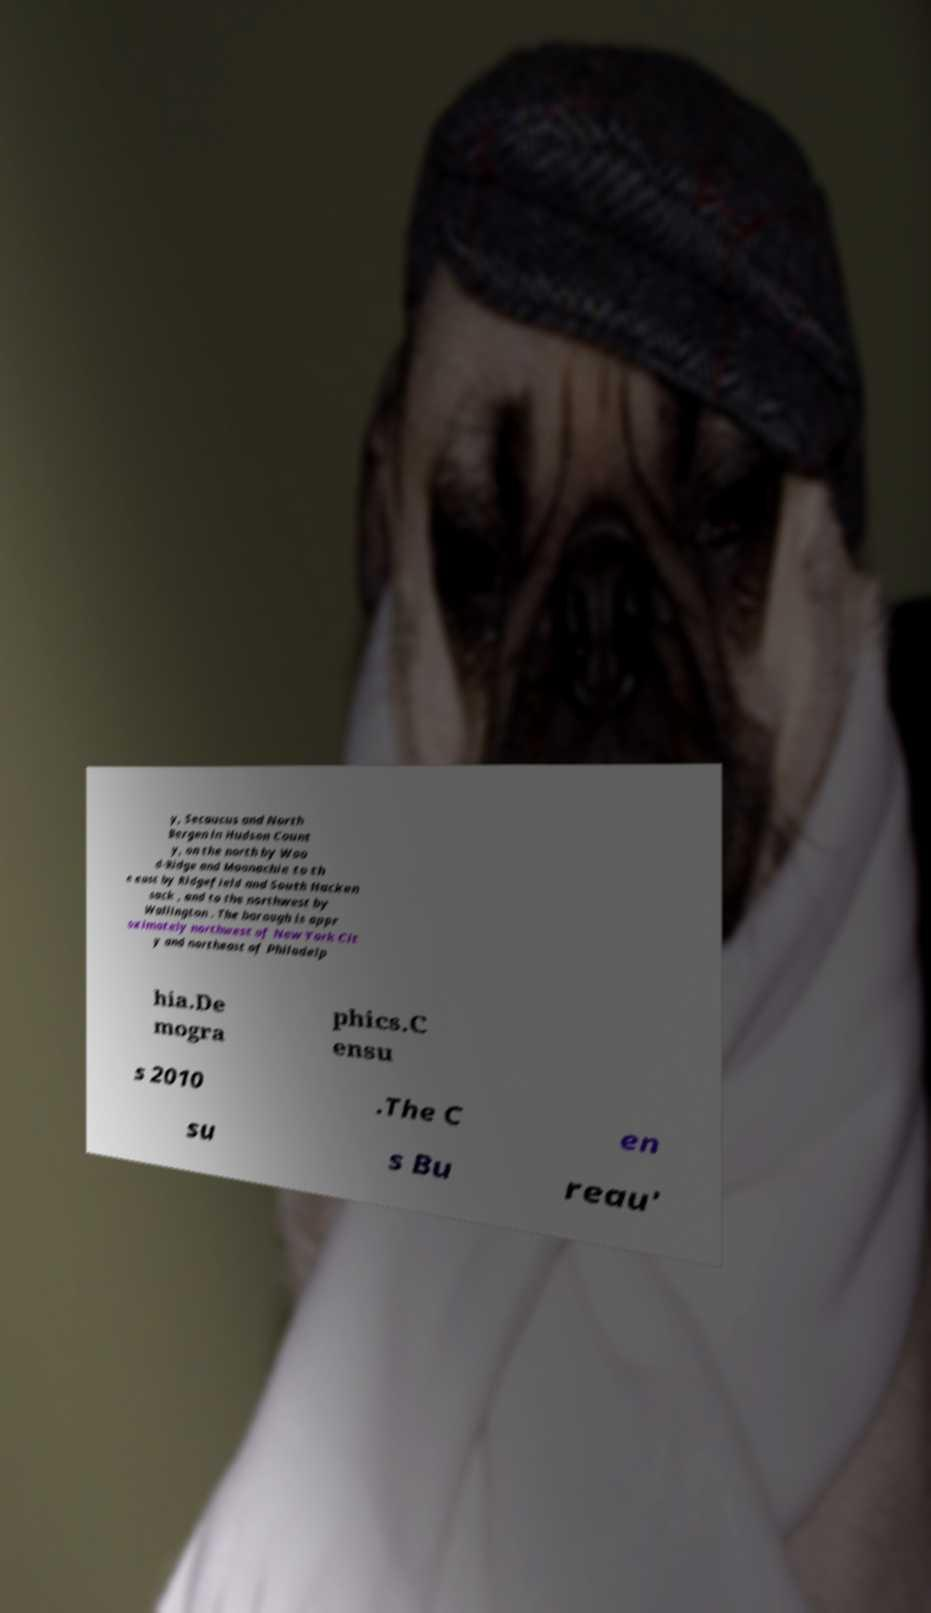Could you assist in decoding the text presented in this image and type it out clearly? y, Secaucus and North Bergen in Hudson Count y, on the north by Woo d-Ridge and Moonachie to th e east by Ridgefield and South Hacken sack , and to the northwest by Wallington . The borough is appr oximately northwest of New York Cit y and northeast of Philadelp hia.De mogra phics.C ensu s 2010 .The C en su s Bu reau' 